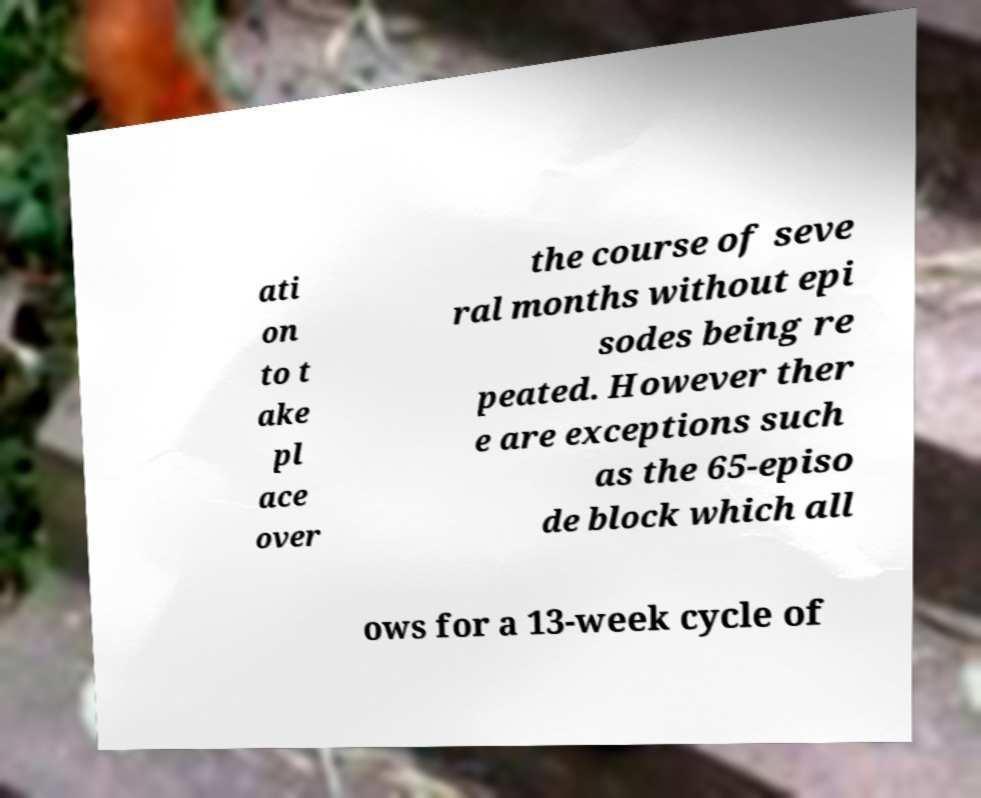Could you extract and type out the text from this image? ati on to t ake pl ace over the course of seve ral months without epi sodes being re peated. However ther e are exceptions such as the 65-episo de block which all ows for a 13-week cycle of 